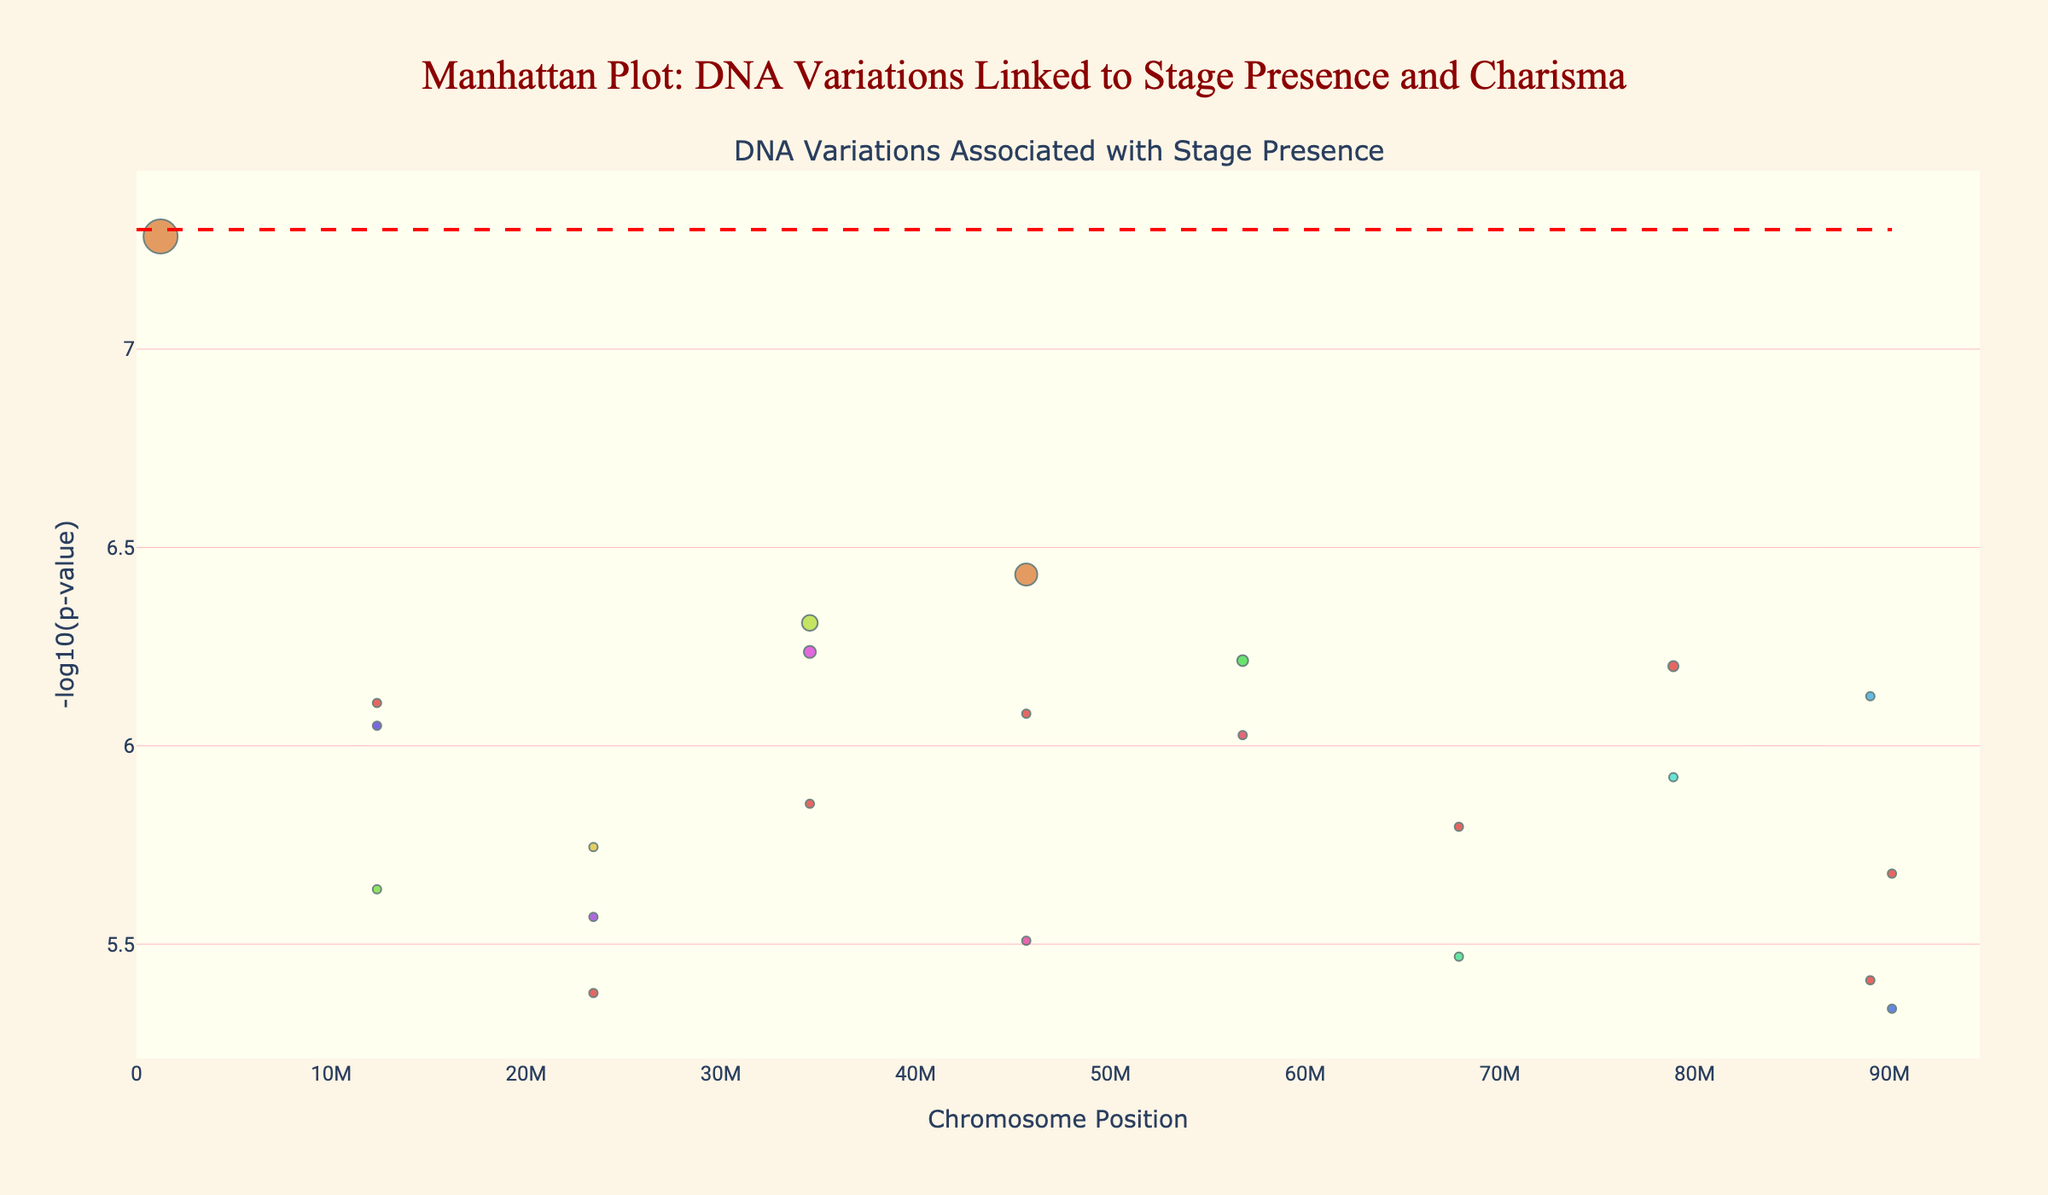what is the title of the plot? The title of the plot is displayed prominently at the top center of the figure. It reads "Manhattan Plot: DNA Variations Linked to Stage Presence and Charisma."
Answer: Manhattan Plot: DNA Variations Linked to Stage Presence and Charisma What is the highest -log10(p-value) observed in the plot? Observe the y-axis values that represent the -log10(p-values). Identify the highest point among the scatter points on this axis.
Answer: 7.28 Which chromosome has the most significant p-value? The red dashed line indicates the significance threshold at -log10(5e-8). The highest point above this line reveals the most significant p-value, and its corresponding chromosome can be traced horizontally. Chromosome 1 has a p-value of 5.2e-8 for the gene OXTR.
Answer: Chromosome 1 What's the p-value associated with the AVPR1A gene on chromosome 1? Locate chromosome 1 on the x-axis, and find the scatter point for AVPR1A. Hovering over this point in the interactive plot reveals the p-value.
Answer: 3.7e-7 How many genes have p-values less than 1e-6? Count the number of scatter points that are above the -log10(1e-6) threshold line. These points represent genes with p-values less than 1e-6.
Answer: 5 Which chromosome has the highest average position? Calculate the average position for each chromosome by summing all positions found within a chromosome and dividing by the number of positions. Compare these averages to find the highest one. Chromosome 19 holds this title.
Answer: Chromosome 19 What colors are used to represent chromosomes in the plot? The colors, mapped from the HSL color space, range differently for each chromosome. Observe the hues applied in a gradient pattern as per their ordinal positions. Specific color details aren't necessary, but recognizing the varied hues suffices.
Answer: Varied hues Which gene corresponds to the p-value of 4.9e-7? Examine the p-values in the figure to find 4.9e-7, follow it horizontally to see the gene name labeled, positioned within chromosome 3.
Answer: COMT Of the genes annotated, which is found on chromosome 20? Verify the chromosome number annotations, then identify the gene names provided within these respective segments. The gene matched for chromosome 20 is NR3C1.
Answer: NR3C1 What is the average -log10(p-value) of genes on chromosome 9? Calculate the -log10(p-values) for genes on chromosome 9 and average them. There is one gene, TPH2, with a -log10(p-value) of 5.34. Hence, the average is 5.34.
Answer: 5.34 